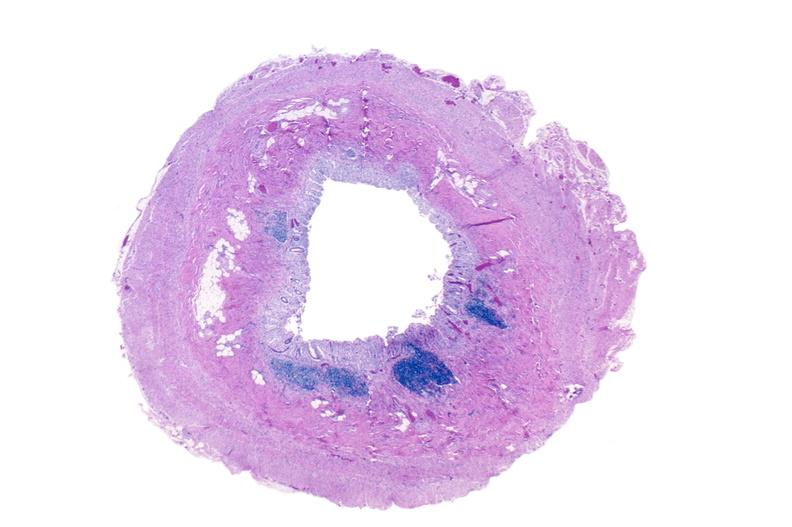what does this image show?
Answer the question using a single word or phrase. Normal appendix 